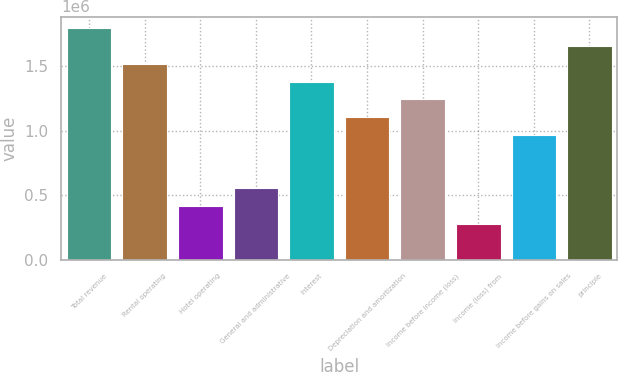Convert chart to OTSL. <chart><loc_0><loc_0><loc_500><loc_500><bar_chart><fcel>Total revenue<fcel>Rental operating<fcel>Hotel operating<fcel>General and administrative<fcel>Interest<fcel>Depreciation and amortization<fcel>Income before income (loss)<fcel>Income (loss) from<fcel>Income before gains on sales<fcel>principle<nl><fcel>1.79772e+06<fcel>1.52115e+06<fcel>414862<fcel>553148<fcel>1.38287e+06<fcel>1.10629e+06<fcel>1.24458e+06<fcel>276576<fcel>968007<fcel>1.65944e+06<nl></chart> 